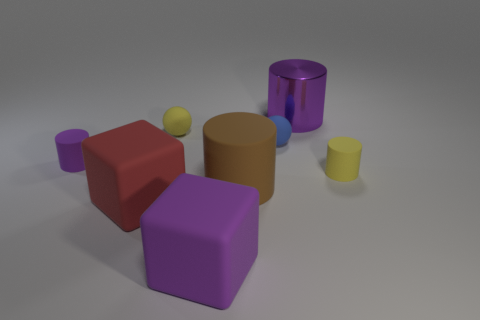Are there any other things that are the same material as the large purple cylinder?
Your response must be concise. No. Does the metal thing have the same color as the cylinder that is left of the tiny yellow ball?
Offer a very short reply. Yes. What is the shape of the small blue thing?
Provide a succinct answer. Sphere. There is a purple cylinder behind the tiny yellow rubber thing on the left side of the small rubber object right of the large metal cylinder; what size is it?
Provide a succinct answer. Large. How many other objects are the same shape as the red rubber thing?
Ensure brevity in your answer.  1. Is the shape of the purple rubber object behind the red thing the same as the big purple thing to the left of the brown cylinder?
Keep it short and to the point. No. What number of spheres are either small things or blue things?
Provide a short and direct response. 2. What is the purple cylinder that is on the right side of the brown thing in front of the big object right of the brown rubber thing made of?
Your response must be concise. Metal. How many other things are the same size as the brown object?
Ensure brevity in your answer.  3. The matte block that is the same color as the large metallic thing is what size?
Your response must be concise. Large. 